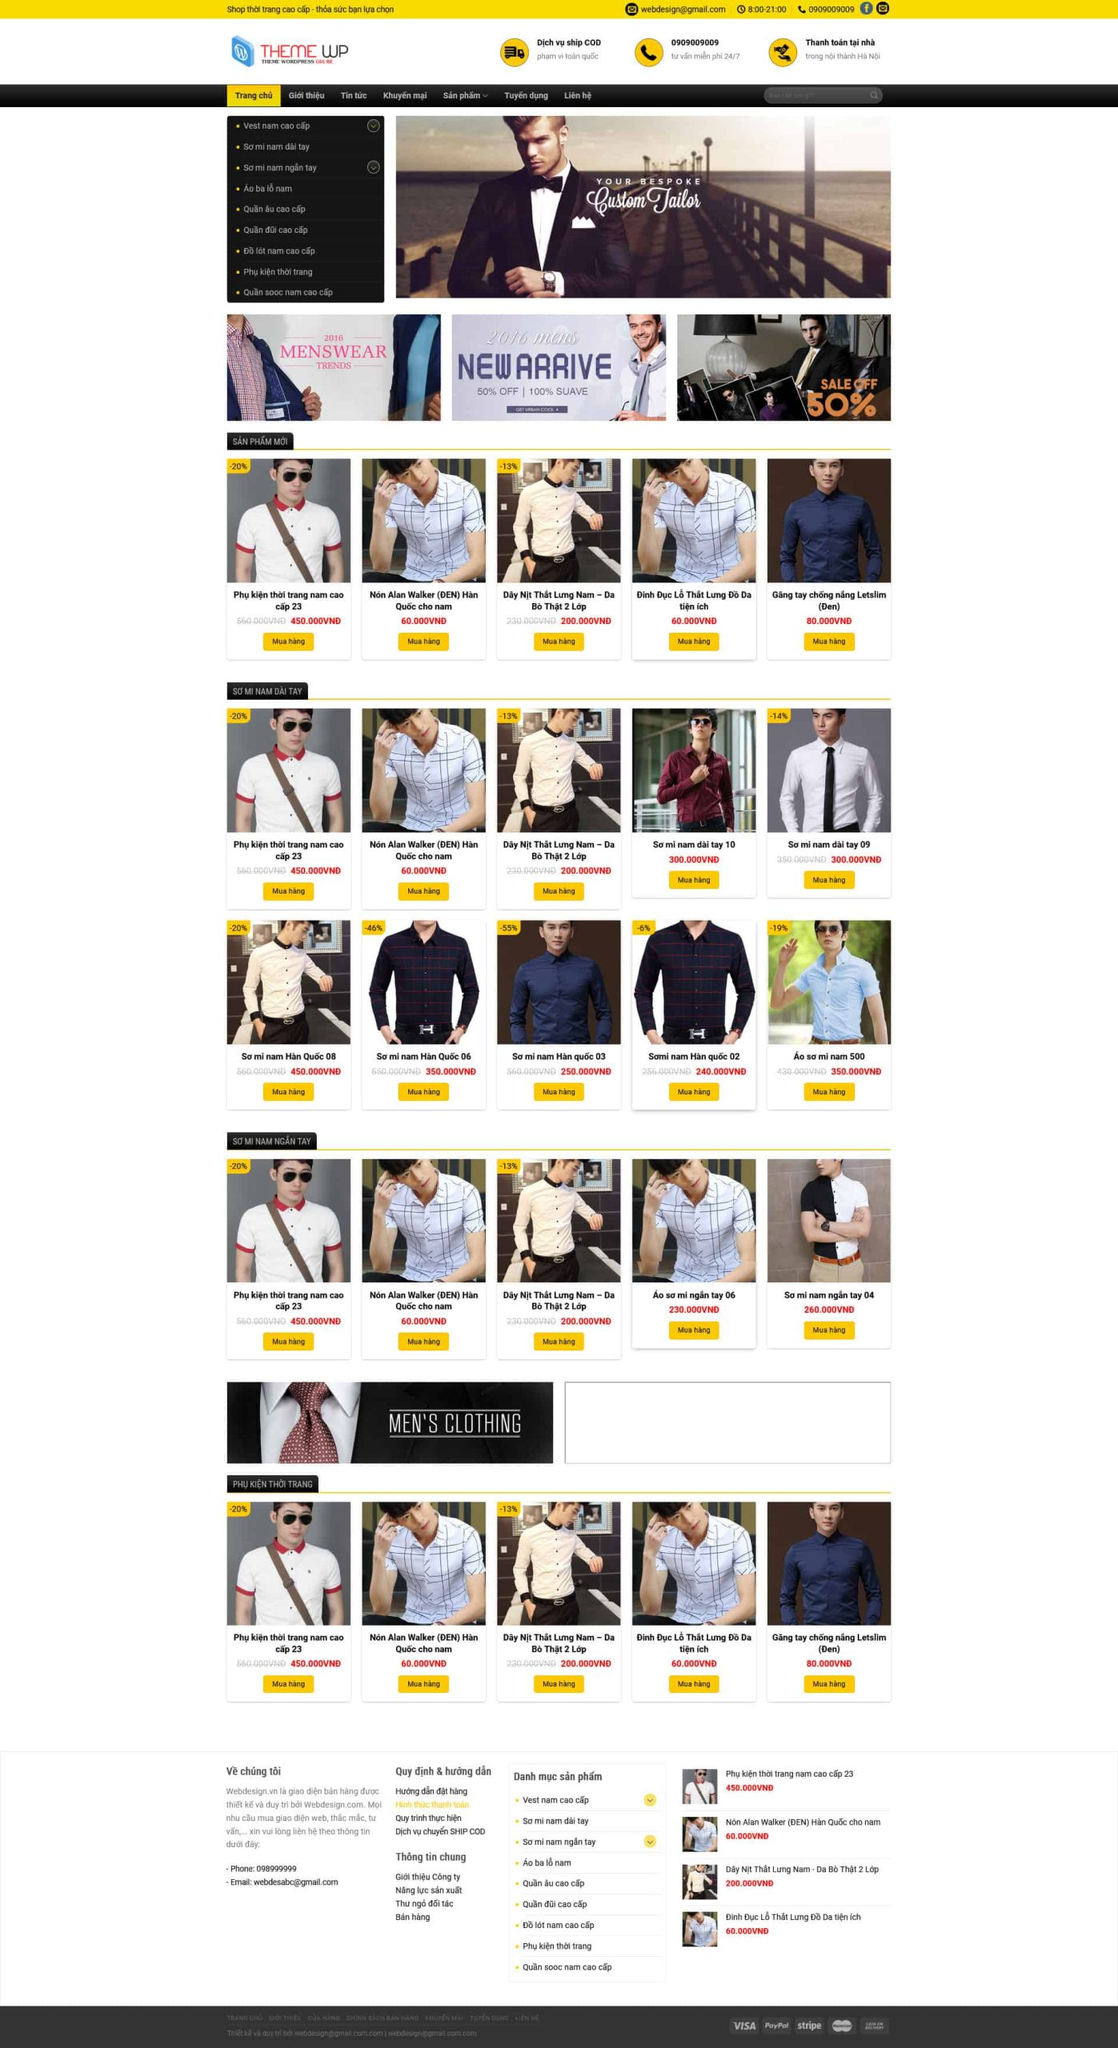Liệt kê 5 ngành nghề, lĩnh vực phù hợp với website này, phân cách các màu sắc bằng dấu phẩy. Chỉ trả về kết quả, phân cách bằng dấy phẩy
 Thời trang nam, Phụ kiện nam, Quần áo công sở, Đồng phục nam, Sơ mi nam 